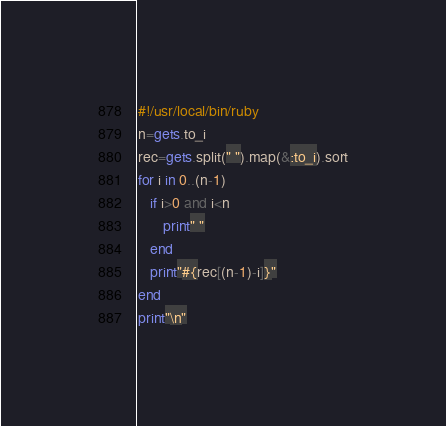<code> <loc_0><loc_0><loc_500><loc_500><_Ruby_>#!/usr/local/bin/ruby
n=gets.to_i
rec=gets.split(" ").map(&:to_i).sort
for i in 0..(n-1)
   if i>0 and i<n
      print" "
   end
   print"#{rec[(n-1)-i]}"
end
print"\n"</code> 